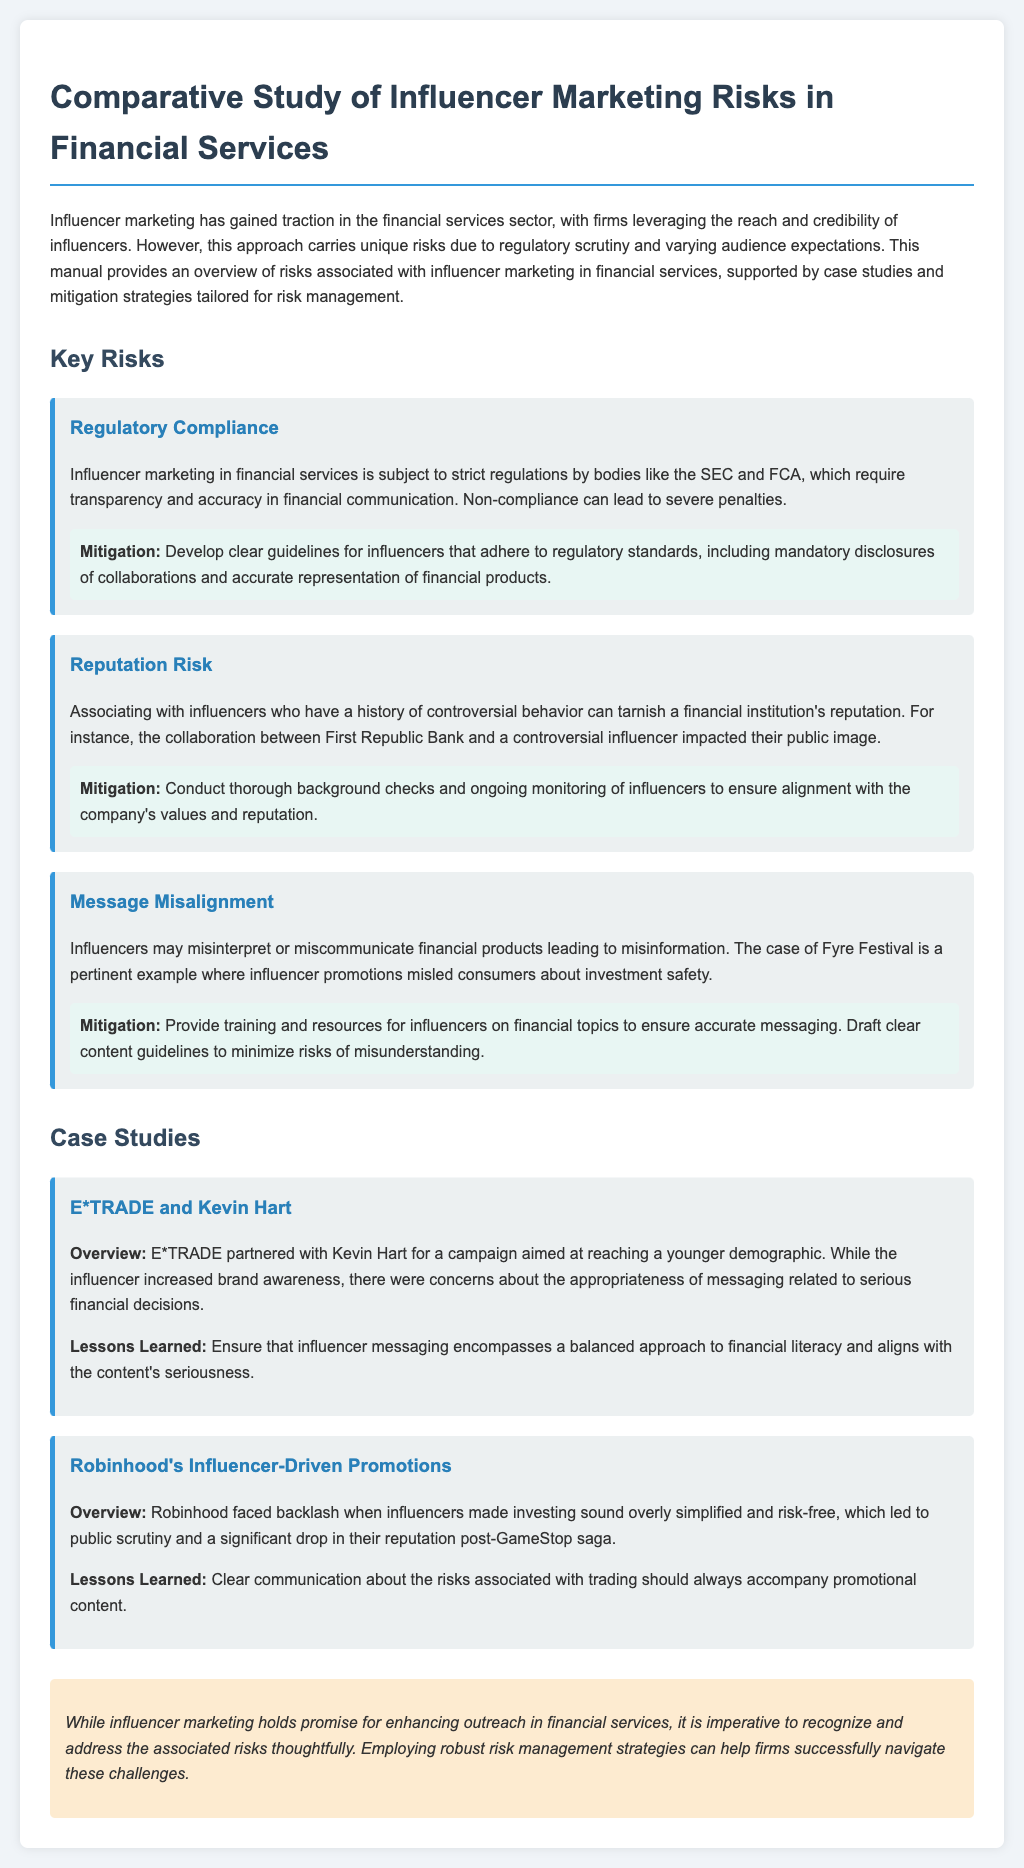What is the title of the document? The title is mentioned in the heading of the document, which provides the main subject of the manual.
Answer: Comparative Study of Influencer Marketing Risks in Financial Services What are the key risks associated with influencer marketing? The document outlines specific risks in a section titled "Key Risks," where each risk is detailed.
Answer: Regulatory Compliance, Reputation Risk, Message Misalignment Which regulatory bodies are mentioned in relation to compliance? The document specifies regulatory bodies that oversee influencer marketing, providing a clear source of authority.
Answer: SEC and FCA What case study involves E*TRADE? The manual references specific case studies, and one of them pertains to E*TRADE.
Answer: E*TRADE and Kevin Hart What is a mitigation strategy for regulatory compliance? The manual lists strategies to counteract risks, including those related to regulatory issues.
Answer: Develop clear guidelines for influencers What was one impact of Robinhood's influencer-driven promotions? The document notes the outcomes of Robinhood's marketing strategies, which affected their public standing.
Answer: Significant drop in their reputation What lesson was learned from the E*TRADE case study? Each case study concludes with lessons learned that highlight essential takeaways for future campaigns.
Answer: Ensure that influencer messaging encompasses a balanced approach to financial literacy Which influencer was involved in the E*TRADE campaign? The campaign's partnership is specifically identified in the case study overview, providing essential detail on influencer selection.
Answer: Kevin Hart What type of risks does influencer marketing in financial services carry? The introduction discusses the nature of risks associated with influencer marketing, especially in this sector.
Answer: Unique risks 